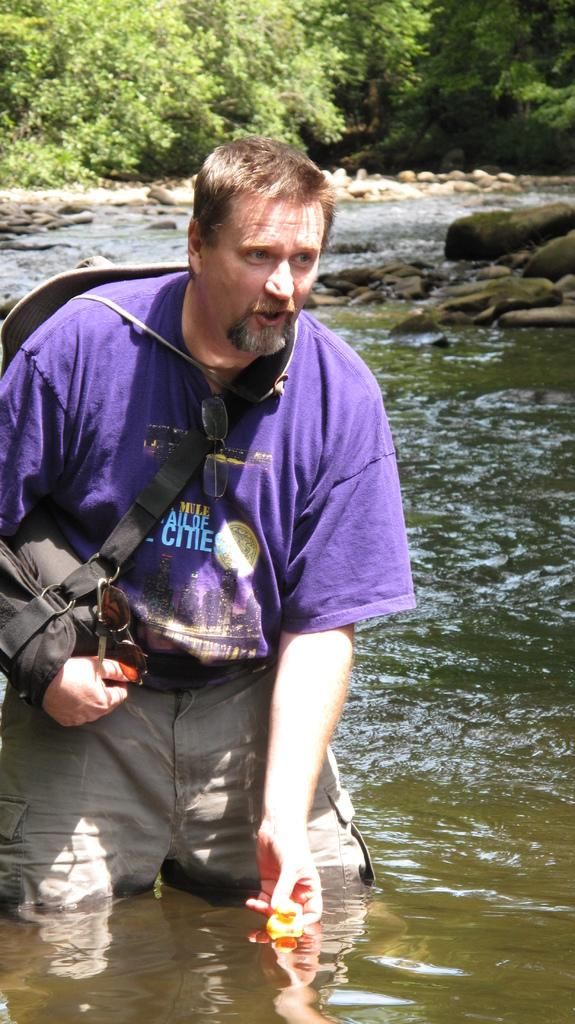What is the main element present in the image? There is water in the image. Can you describe the person in the image? There is a man in the image, and he is wearing a purple t-shirt. What can be seen in the background of the image? There are stones and trees in the background of the image. What type of treatment is the man receiving in the image? There is no indication in the image that the man is receiving any treatment. Can you describe the parcel that the man is holding in the image? There is no parcel present in the image; the man is not holding anything. 